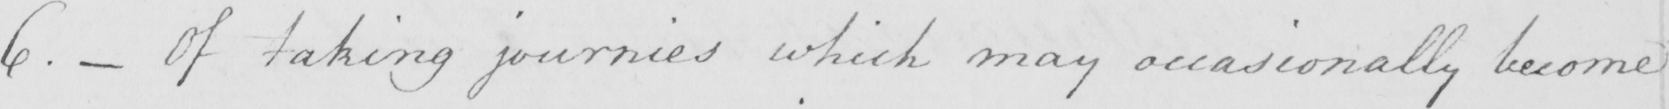Please transcribe the handwritten text in this image. 6 .  _  Of taking journies which may occasionally become 